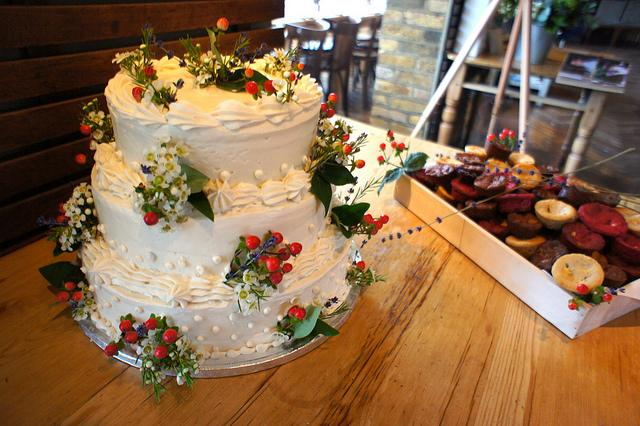Bakers usually charge by the what to make these items? hour 